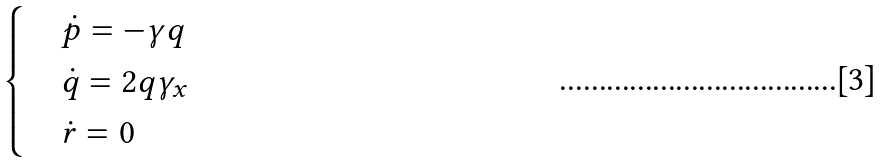Convert formula to latex. <formula><loc_0><loc_0><loc_500><loc_500>\begin{cases} & \dot { p } = - \gamma q \\ & \dot { q } = 2 q \gamma _ { x } \\ & \dot { r } = 0 \end{cases}</formula> 